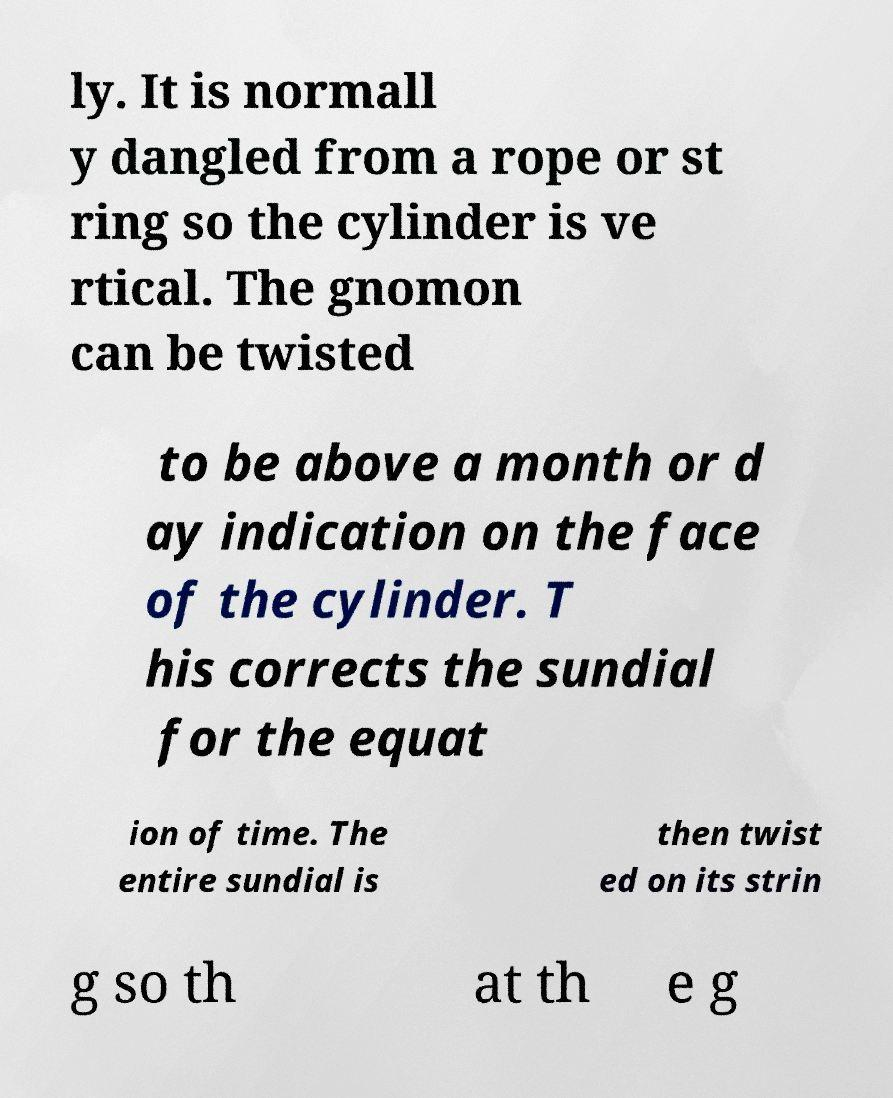What messages or text are displayed in this image? I need them in a readable, typed format. ly. It is normall y dangled from a rope or st ring so the cylinder is ve rtical. The gnomon can be twisted to be above a month or d ay indication on the face of the cylinder. T his corrects the sundial for the equat ion of time. The entire sundial is then twist ed on its strin g so th at th e g 